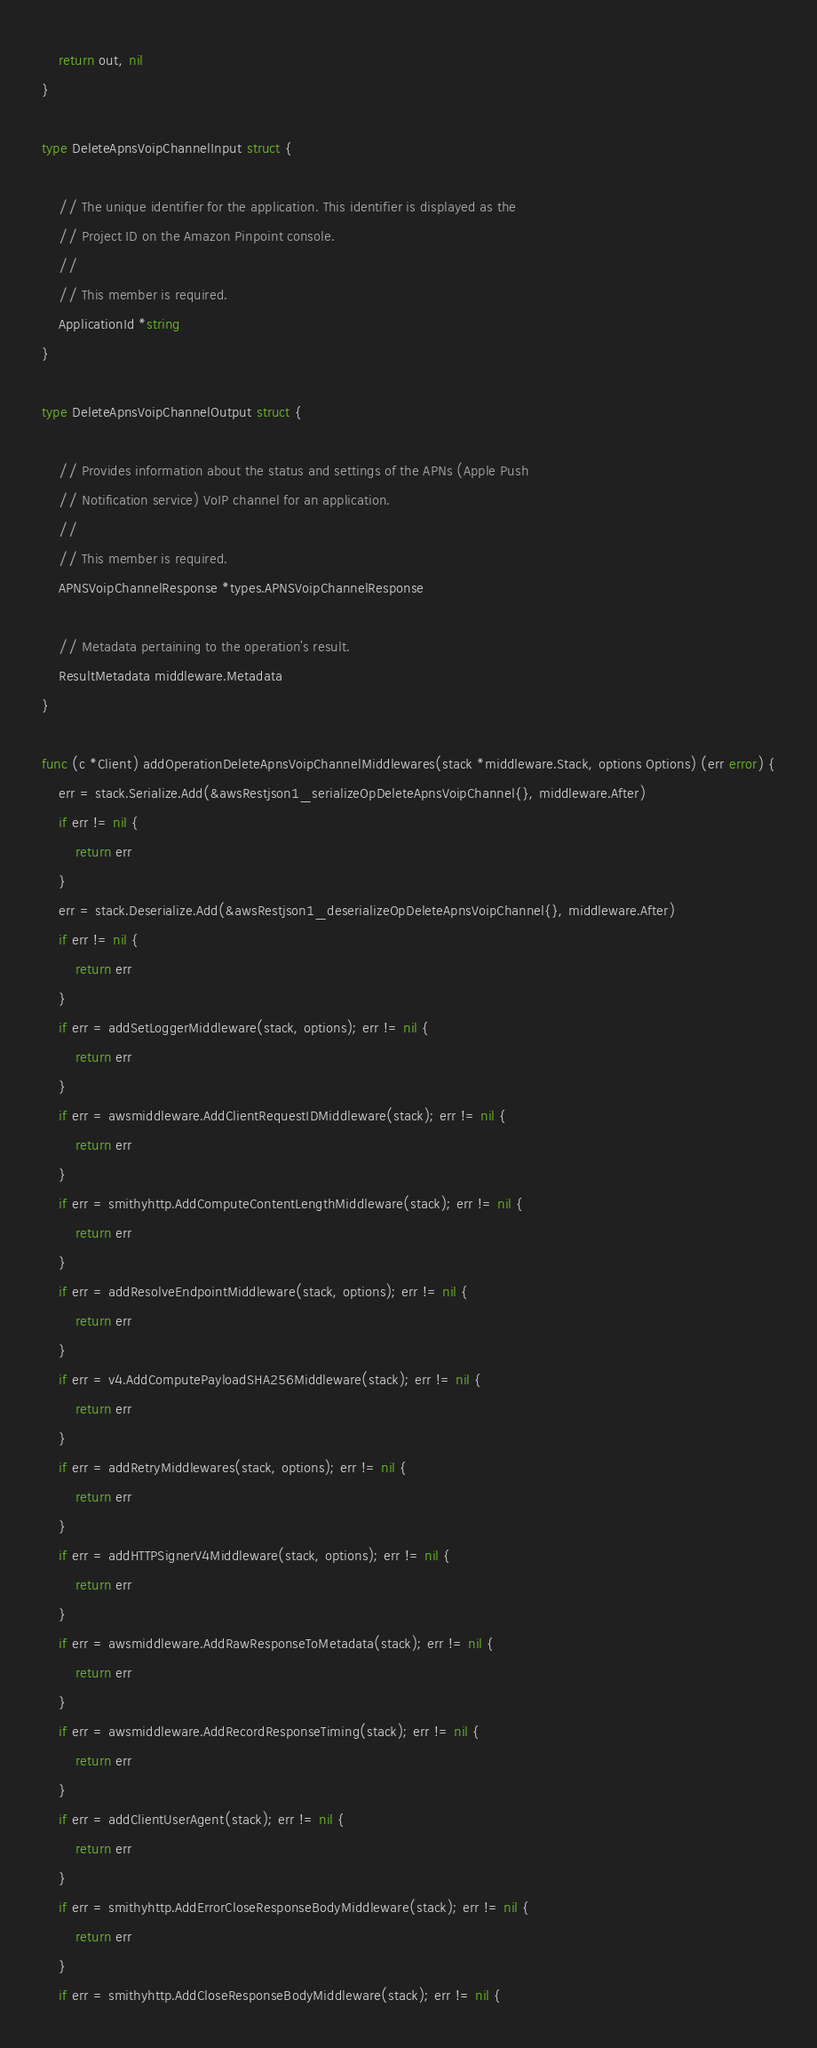Convert code to text. <code><loc_0><loc_0><loc_500><loc_500><_Go_>	return out, nil
}

type DeleteApnsVoipChannelInput struct {

	// The unique identifier for the application. This identifier is displayed as the
	// Project ID on the Amazon Pinpoint console.
	//
	// This member is required.
	ApplicationId *string
}

type DeleteApnsVoipChannelOutput struct {

	// Provides information about the status and settings of the APNs (Apple Push
	// Notification service) VoIP channel for an application.
	//
	// This member is required.
	APNSVoipChannelResponse *types.APNSVoipChannelResponse

	// Metadata pertaining to the operation's result.
	ResultMetadata middleware.Metadata
}

func (c *Client) addOperationDeleteApnsVoipChannelMiddlewares(stack *middleware.Stack, options Options) (err error) {
	err = stack.Serialize.Add(&awsRestjson1_serializeOpDeleteApnsVoipChannel{}, middleware.After)
	if err != nil {
		return err
	}
	err = stack.Deserialize.Add(&awsRestjson1_deserializeOpDeleteApnsVoipChannel{}, middleware.After)
	if err != nil {
		return err
	}
	if err = addSetLoggerMiddleware(stack, options); err != nil {
		return err
	}
	if err = awsmiddleware.AddClientRequestIDMiddleware(stack); err != nil {
		return err
	}
	if err = smithyhttp.AddComputeContentLengthMiddleware(stack); err != nil {
		return err
	}
	if err = addResolveEndpointMiddleware(stack, options); err != nil {
		return err
	}
	if err = v4.AddComputePayloadSHA256Middleware(stack); err != nil {
		return err
	}
	if err = addRetryMiddlewares(stack, options); err != nil {
		return err
	}
	if err = addHTTPSignerV4Middleware(stack, options); err != nil {
		return err
	}
	if err = awsmiddleware.AddRawResponseToMetadata(stack); err != nil {
		return err
	}
	if err = awsmiddleware.AddRecordResponseTiming(stack); err != nil {
		return err
	}
	if err = addClientUserAgent(stack); err != nil {
		return err
	}
	if err = smithyhttp.AddErrorCloseResponseBodyMiddleware(stack); err != nil {
		return err
	}
	if err = smithyhttp.AddCloseResponseBodyMiddleware(stack); err != nil {</code> 